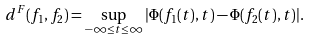Convert formula to latex. <formula><loc_0><loc_0><loc_500><loc_500>d ^ { F } ( f _ { 1 } , f _ { 2 } ) = \sup _ { - \infty \leq t \leq \infty } | \Phi ( f _ { 1 } ( t ) , t ) - \Phi ( f _ { 2 } ( t ) , t ) | .</formula> 